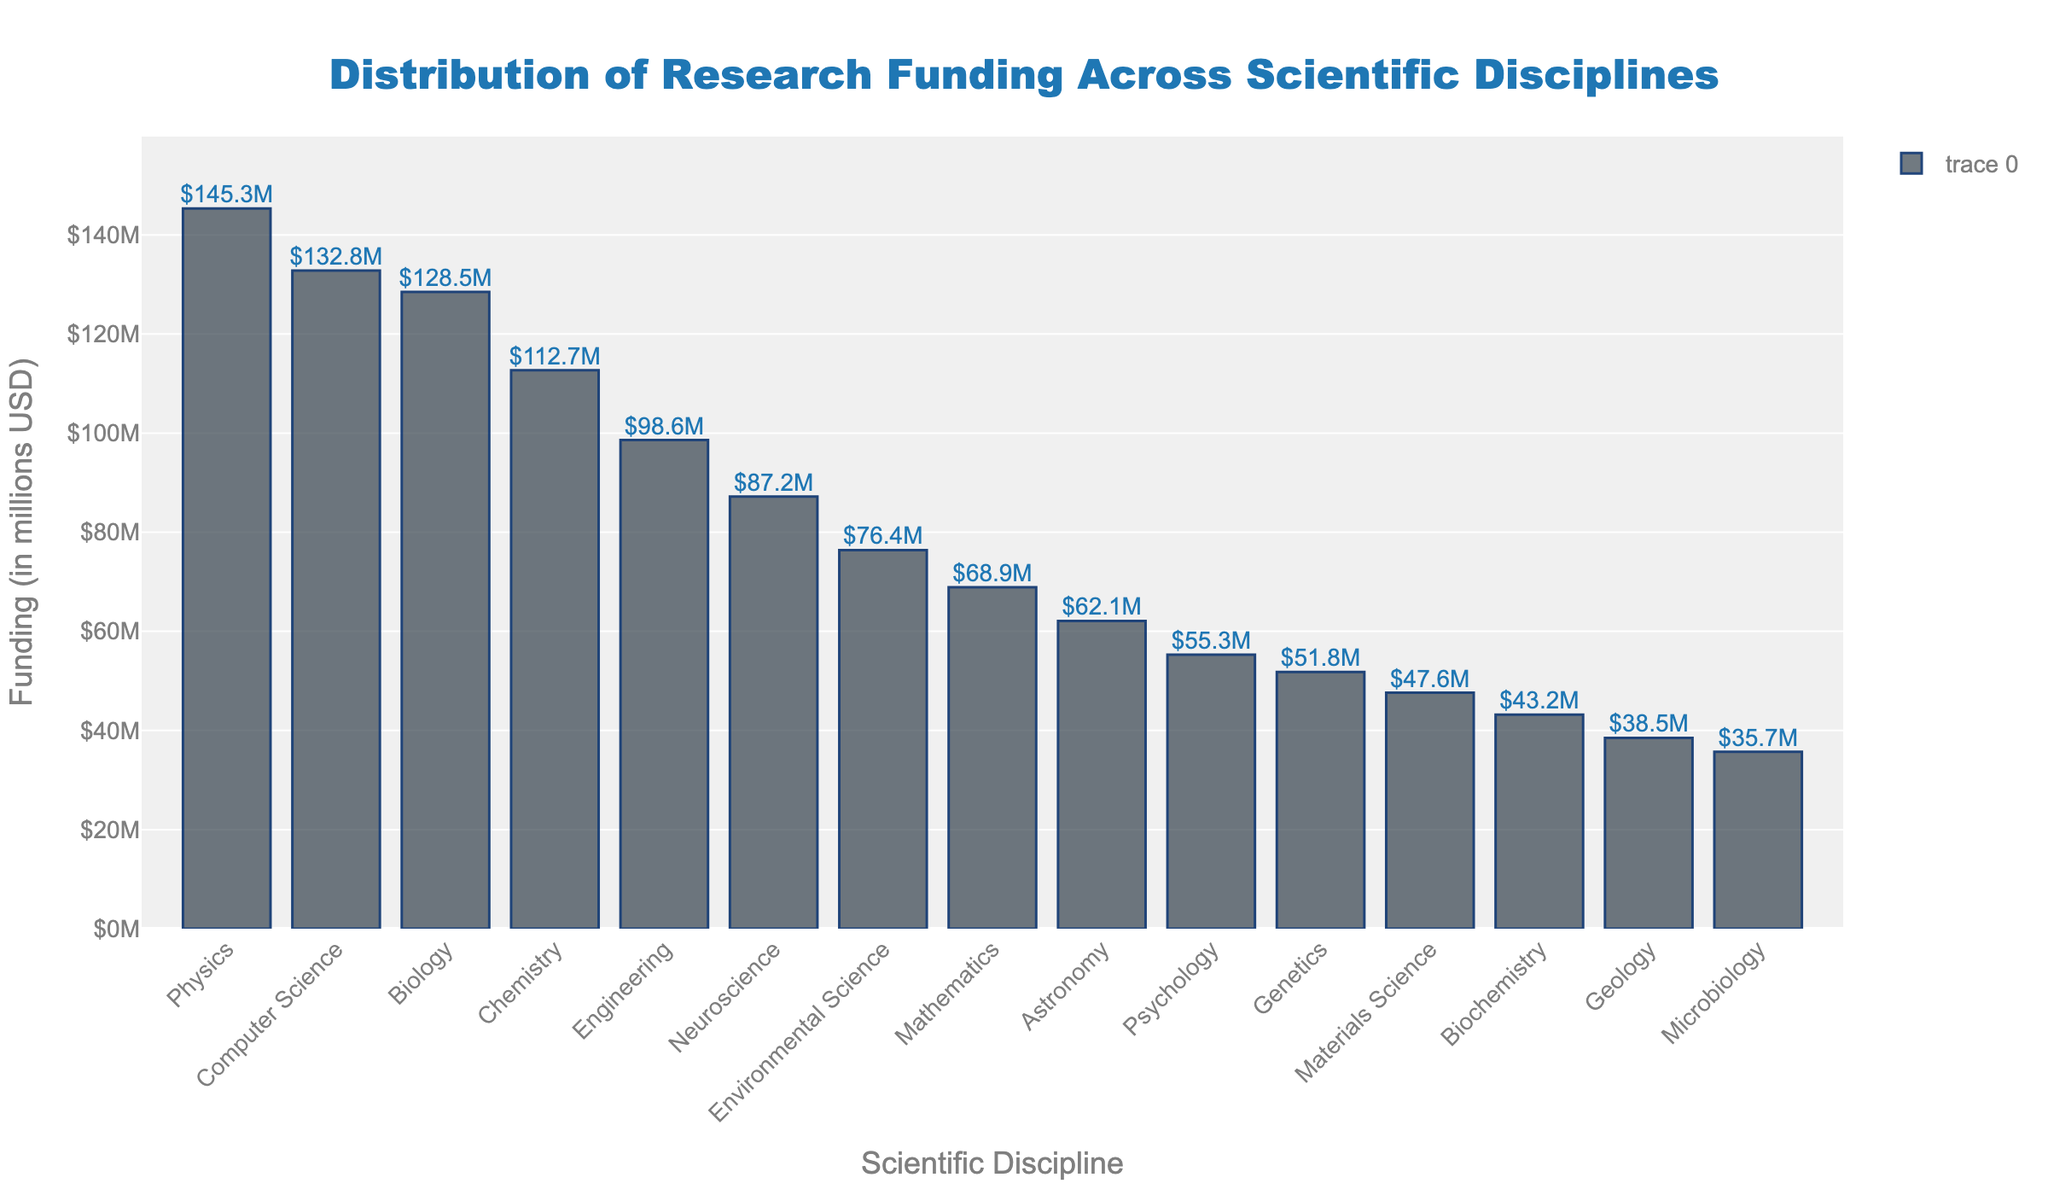Which discipline received the highest funding? The bar representing Physics is the highest, indicating that Physics received the highest funding.
Answer: Physics What is the total funding received by the top 3 disciplines? The top 3 disciplines are Physics, Computer Science, and Biology with respective funding of 145.3M, 132.8M, and 128.5M. Summing these values gives 145.3 + 132.8 + 128.5 = 406.6.
Answer: 406.6M How much more funding does Physics receive compared to Psychology? Physics funding is 145.3M and Psychology funding is 55.3M. The difference is 145.3 - 55.3 = 90.
Answer: 90M Which discipline has nearly the same funding as Chemistry? The bars for Chemistry and Engineering are close in height. Chemistry has 112.7M and Engineering has 98.6M.
Answer: Engineering If the funding for Mathematics was increased by 10M, would it surpass Environmental Science in funding? Mathematics has 68.9M and Environmental Science has 76.4M. Increasing Mathematics' funding by 10M results in 68.9 + 10 = 78.9, which is greater than 76.4.
Answer: Yes What's the average funding among the bottom 5 disciplines? The bottom 5 disciplines are Genetics, Materials Science, Biochemistry, Geology, and Microbiology with respective funding of 51.8M, 47.6M, 43.2M, 38.5M, and 35.7M. The sum is 51.8 + 47.6 + 43.2 + 38.5 + 35.7 = 216.8. The average is 216.8 / 5 = 43.36.
Answer: 43.36M Which discipline has more funding: Computer Science or Engineering combined with Neuroscience? Computer Science funding is 132.8M. Combined funding for Engineering and Neuroscience is 98.6 + 87.2 = 185.8, which is greater than 132.8.
Answer: Engineering and Neuroscience What is the rank of Genetics in terms of funding received? By inspecting bar heights from highest to lowest, Genetics appears to be ranked 11th.
Answer: 11th Which disciplines have a funding amount that lies between 50M and 100M? The applicable disciplines based on bar heights and funding values are Engineering (98.6M), Neuroscience (87.2M), Environmental Science (76.4M), and Psychology (55.3M).
Answer: Engineering, Neuroscience, Environmental Science, Psychology If the funding for Biochemistry was doubled, would it reach or exceed Astronomy's funding? Biochemistry currently has 43.2M. Doubling this results in 43.2 * 2 = 86.4, which is greater than Astronomy's 62.1M.
Answer: Yes 